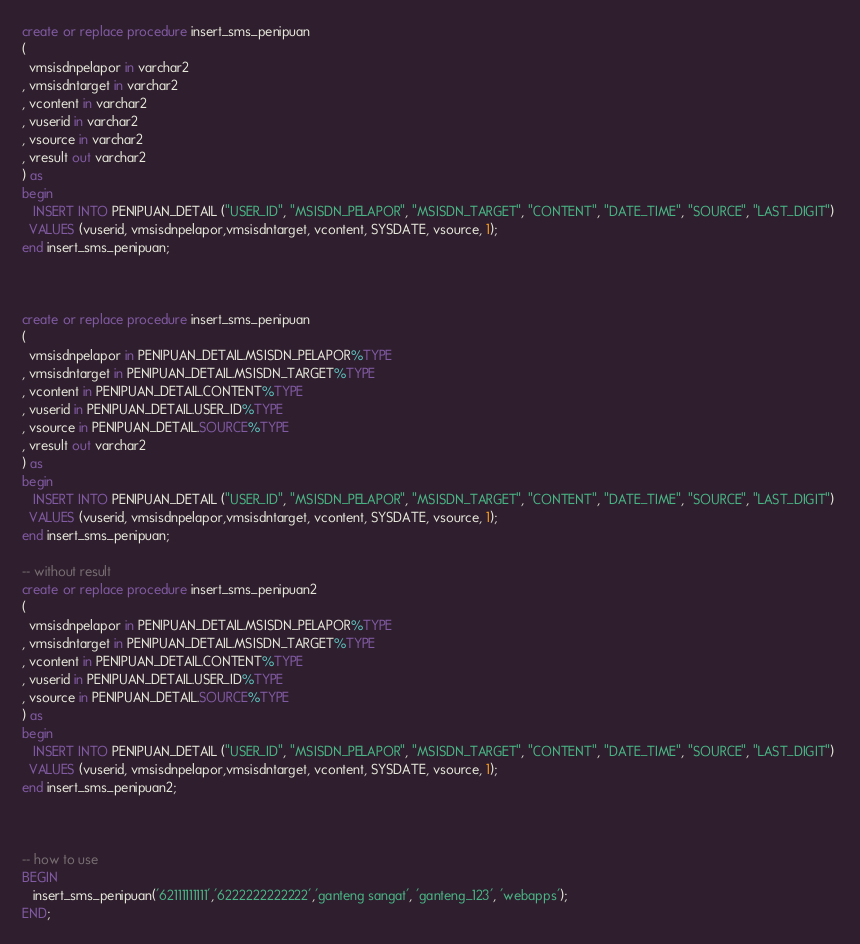Convert code to text. <code><loc_0><loc_0><loc_500><loc_500><_SQL_>create or replace procedure insert_sms_penipuan 
(
  vmsisdnpelapor in varchar2 
, vmsisdntarget in varchar2 
, vcontent in varchar2 
, vuserid in varchar2 
, vsource in varchar2 
, vresult out varchar2 
) as 
begin
   INSERT INTO PENIPUAN_DETAIL ("USER_ID", "MSISDN_PELAPOR", "MSISDN_TARGET", "CONTENT", "DATE_TIME", "SOURCE", "LAST_DIGIT") 
  VALUES (vuserid, vmsisdnpelapor,vmsisdntarget, vcontent, SYSDATE, vsource, 1);
end insert_sms_penipuan;



create or replace procedure insert_sms_penipuan 
(
  vmsisdnpelapor in PENIPUAN_DETAIL.MSISDN_PELAPOR%TYPE
, vmsisdntarget in PENIPUAN_DETAIL.MSISDN_TARGET%TYPE
, vcontent in PENIPUAN_DETAIL.CONTENT%TYPE
, vuserid in PENIPUAN_DETAIL.USER_ID%TYPE
, vsource in PENIPUAN_DETAIL.SOURCE%TYPE
, vresult out varchar2 
) as 
begin
   INSERT INTO PENIPUAN_DETAIL ("USER_ID", "MSISDN_PELAPOR", "MSISDN_TARGET", "CONTENT", "DATE_TIME", "SOURCE", "LAST_DIGIT") 
  VALUES (vuserid, vmsisdnpelapor,vmsisdntarget, vcontent, SYSDATE, vsource, 1);
end insert_sms_penipuan;

-- without result
create or replace procedure insert_sms_penipuan2
(
  vmsisdnpelapor in PENIPUAN_DETAIL.MSISDN_PELAPOR%TYPE
, vmsisdntarget in PENIPUAN_DETAIL.MSISDN_TARGET%TYPE
, vcontent in PENIPUAN_DETAIL.CONTENT%TYPE
, vuserid in PENIPUAN_DETAIL.USER_ID%TYPE
, vsource in PENIPUAN_DETAIL.SOURCE%TYPE
) as 
begin
   INSERT INTO PENIPUAN_DETAIL ("USER_ID", "MSISDN_PELAPOR", "MSISDN_TARGET", "CONTENT", "DATE_TIME", "SOURCE", "LAST_DIGIT") 
  VALUES (vuserid, vmsisdnpelapor,vmsisdntarget, vcontent, SYSDATE, vsource, 1);
end insert_sms_penipuan2;



-- how to use
BEGIN
   insert_sms_penipuan('62111111111','6222222222222','ganteng sangat', 'ganteng_123', 'webapps');
END;
</code> 